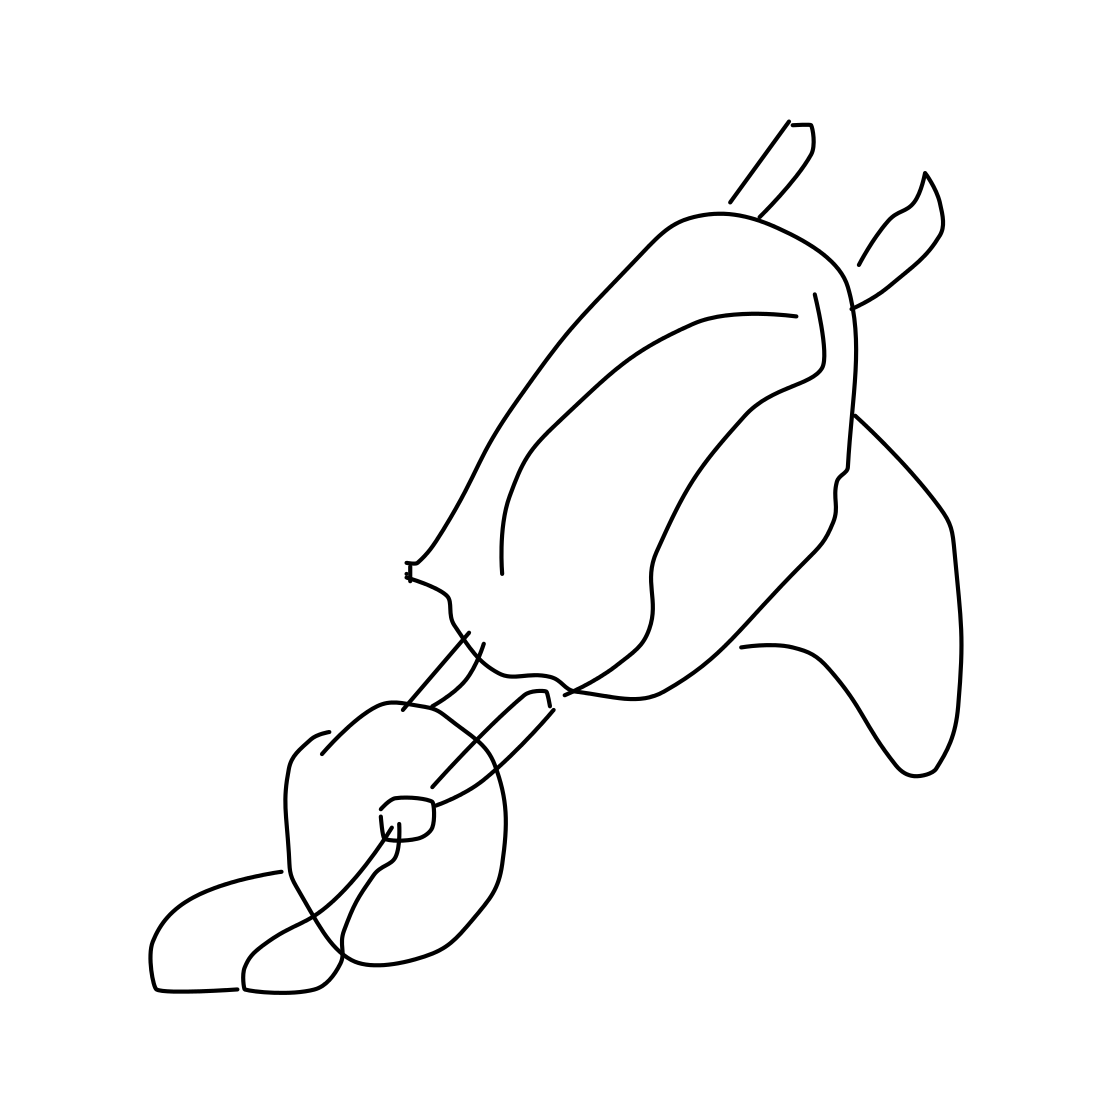Can you tell me what the style of drawing is in this image? The drawing style appears to be very minimalistic and non-detailed, using simple lines and shapes to suggest the form of a wheelbarrow rather than depicting it with realism or detail. 